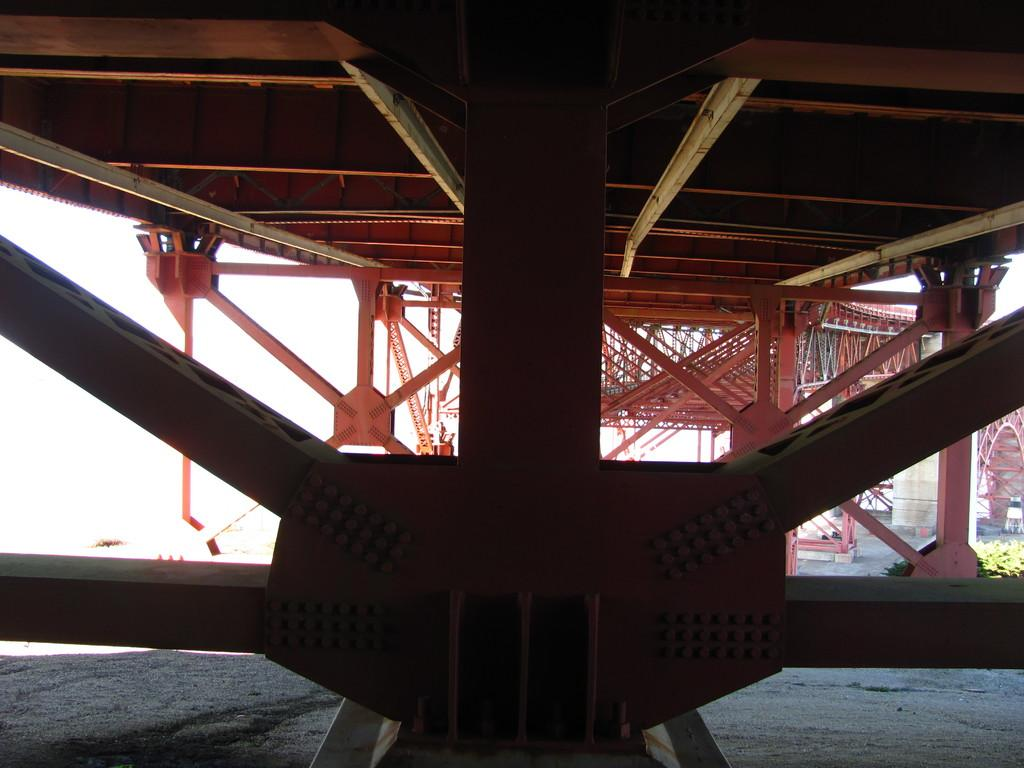What type of structure is present in the image? There is a bridge in the image. What material is used for the rods in the image? The rods in the image are made of metal. What other architectural feature can be seen in the image? There is a wall in the image. What type of natural elements are present in the image? There are plants in the image. How many beads are hanging from the bridge in the image? There are no beads present in the image. What type of shade is provided by the plants in the image? The plants in the image do not provide any shade; they are simply present as natural elements. 